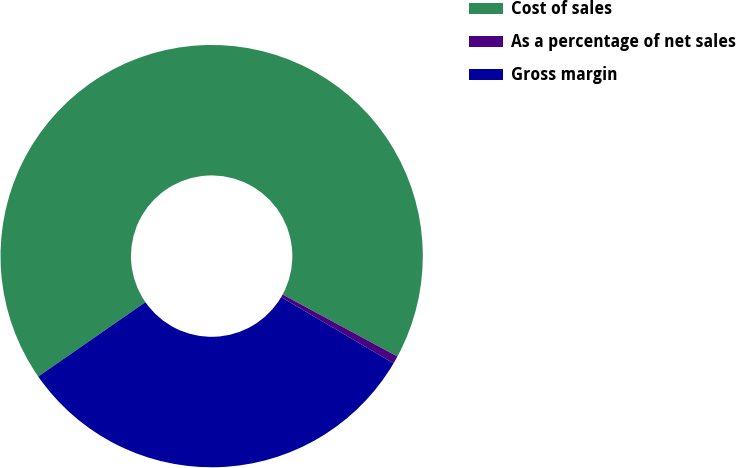Convert chart to OTSL. <chart><loc_0><loc_0><loc_500><loc_500><pie_chart><fcel>Cost of sales<fcel>As a percentage of net sales<fcel>Gross margin<nl><fcel>67.54%<fcel>0.59%<fcel>31.86%<nl></chart> 